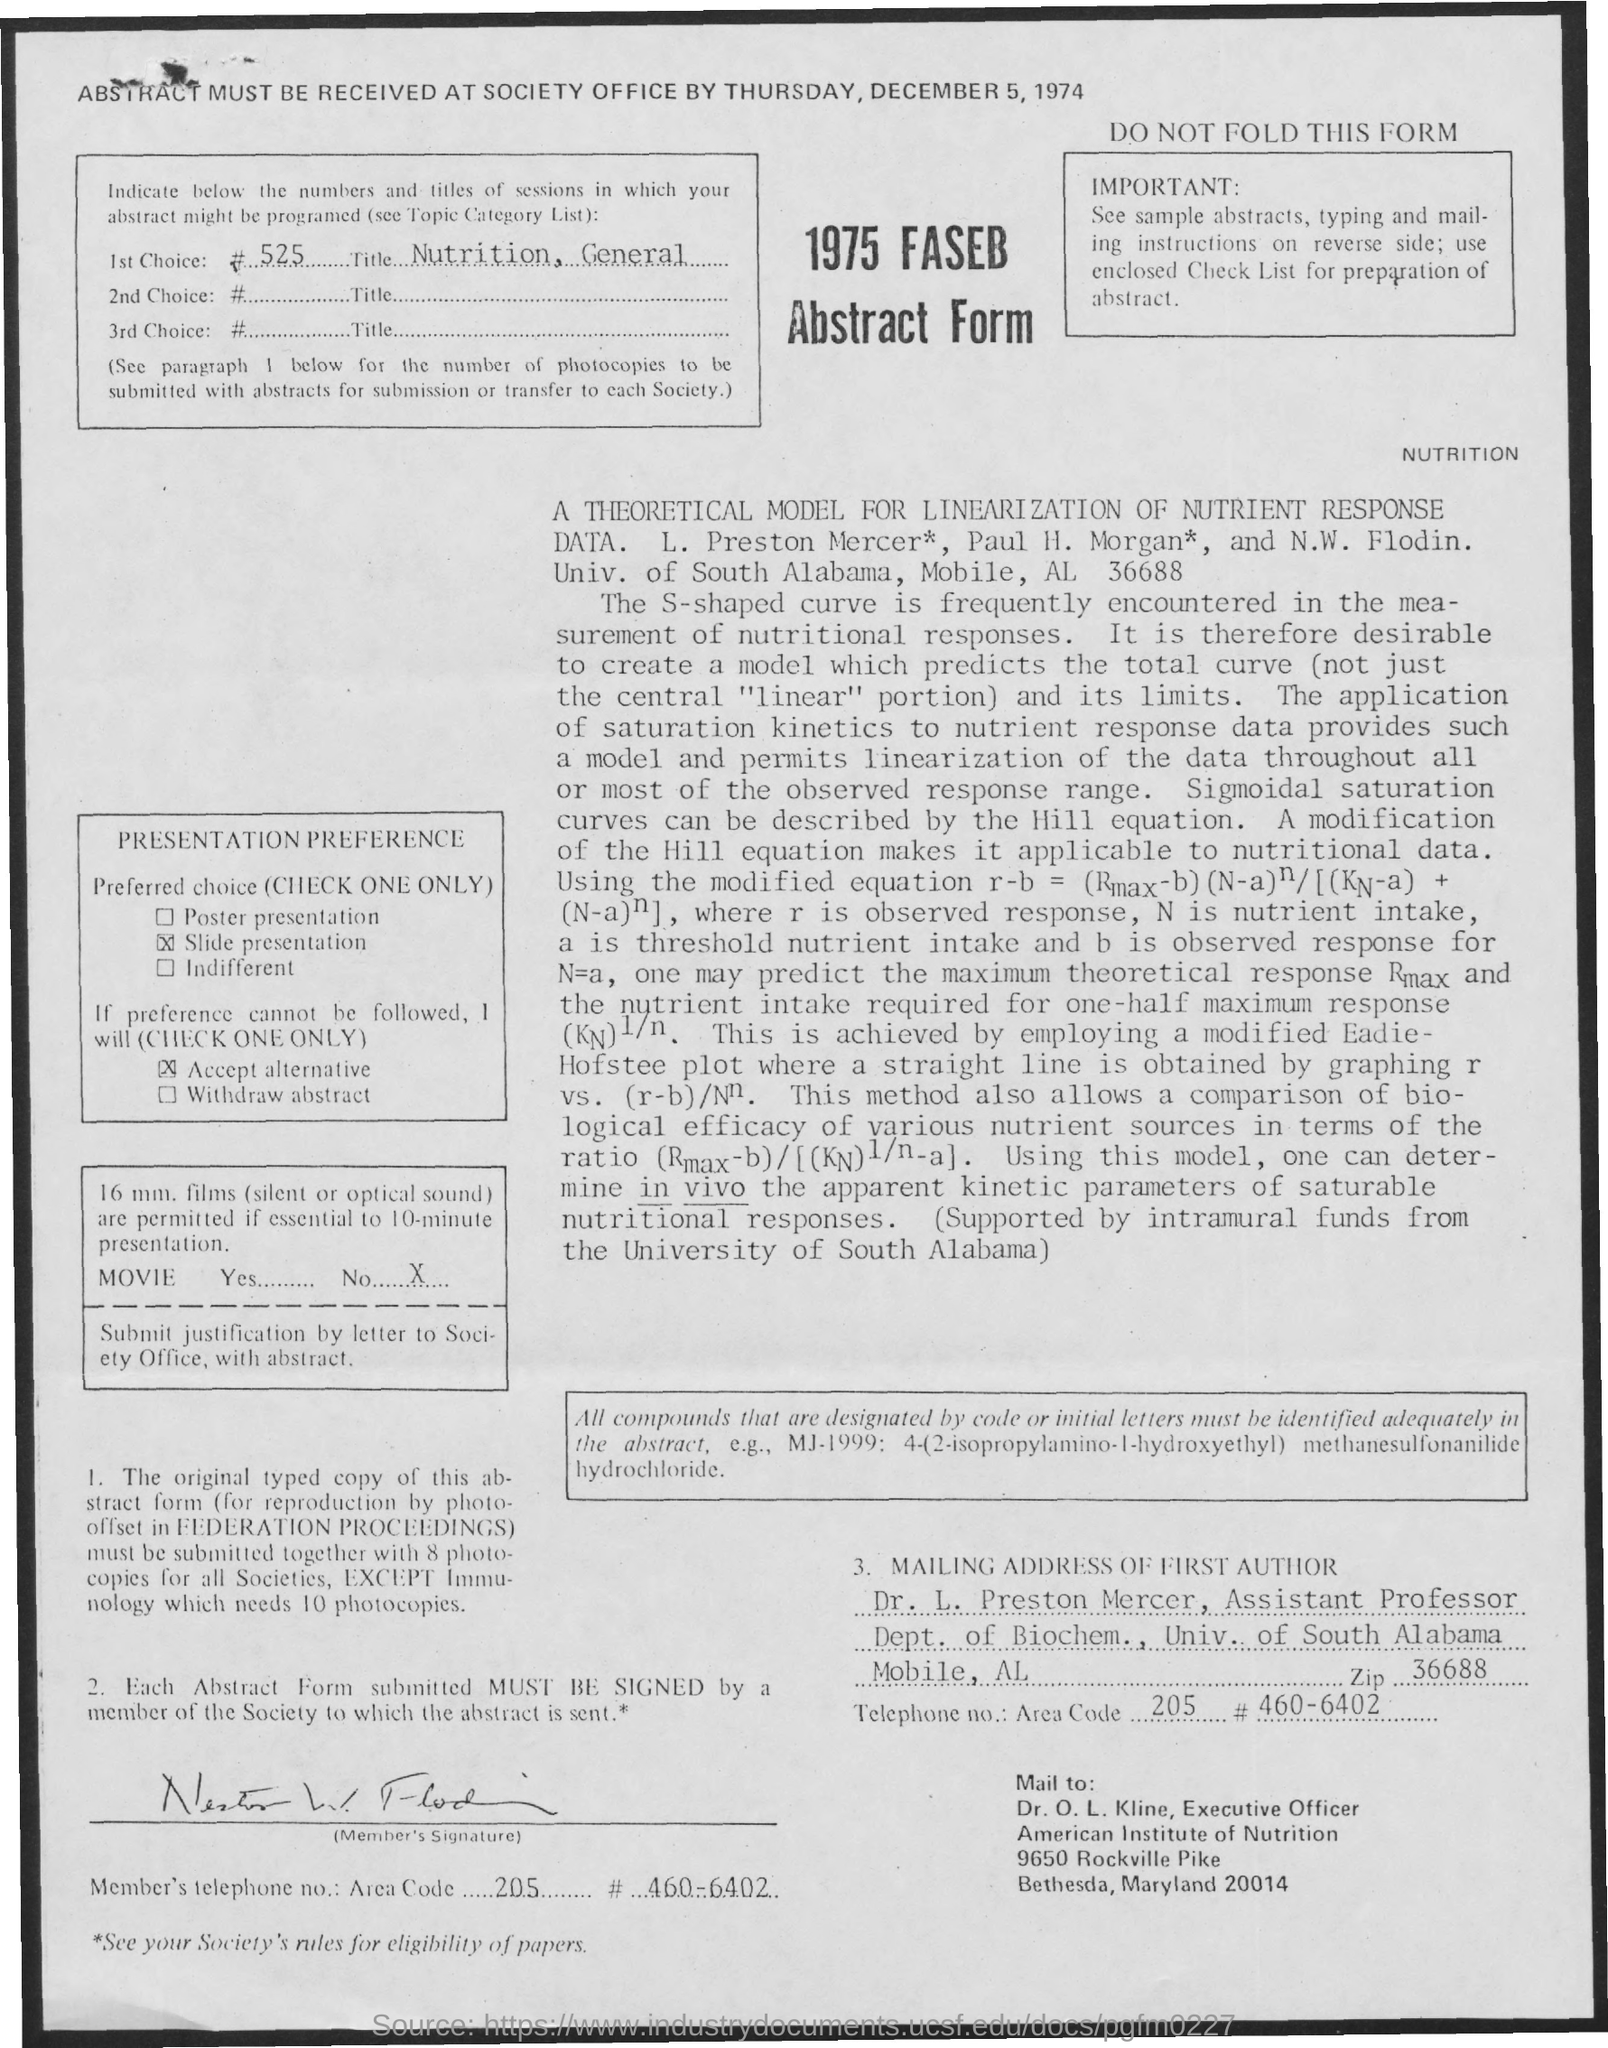Whose name is mentioned in the mailing address of first author ?
Offer a very short reply. Dr. L. Preston Mercer. What is the designation of dr. l. preston mercer
Ensure brevity in your answer.  Assistant professor. What is the name of the university mentioned in the mailing address of first author
Your response must be concise. Univ . of south alabama. What is the of the zipcode  mentioned in the mailing address of first author
Your response must be concise. 36688. What is the designation  of dr. o.l. kline
Your answer should be very brief. Executive officer. By when the abstract must be received at society office
Your answer should be very brief. By thursday, december 5, 1974. 